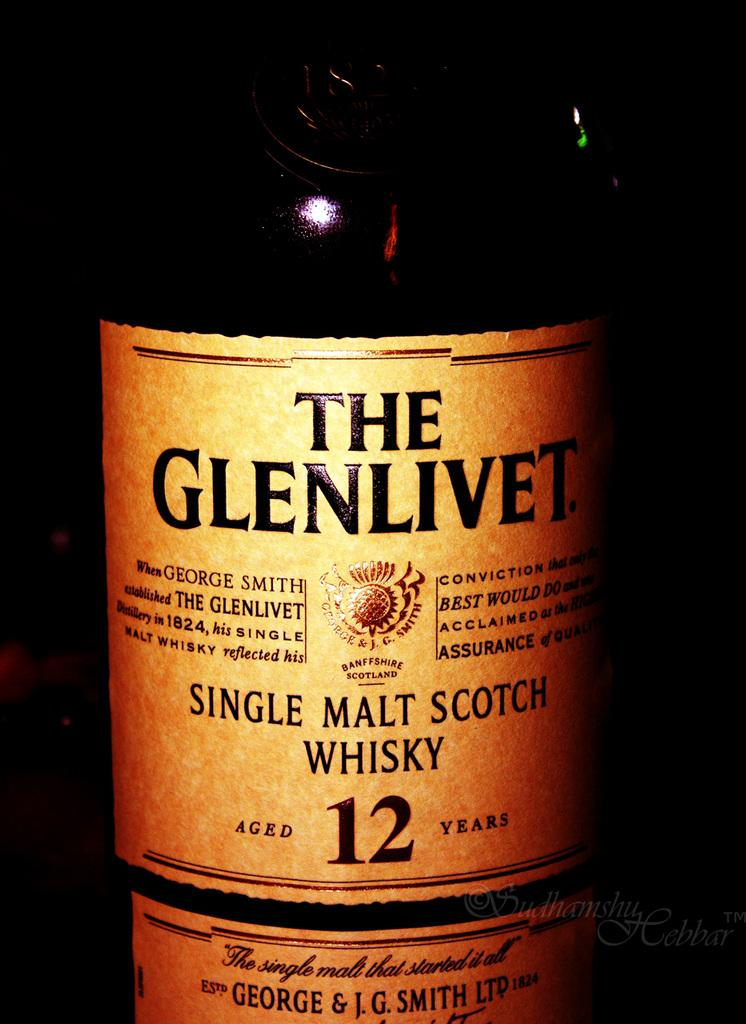<image>
Present a compact description of the photo's key features. A bottle of single malt scotch whisky aged 12 years 